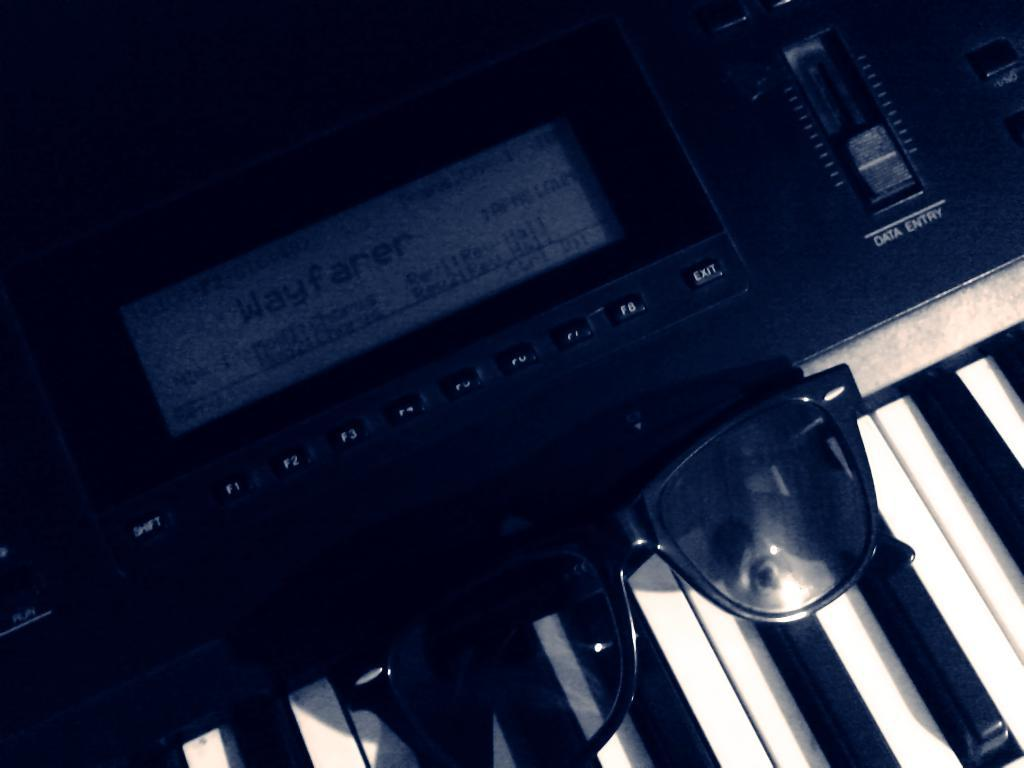What musical instrument is present in the image? There is a piano in the image. What type of accessory can be seen in the image? There are goggles in black color in the image. How does the piano affect the singer's throat in the image? There is no singer or throat mentioned in the image; it only features a piano and goggles. 